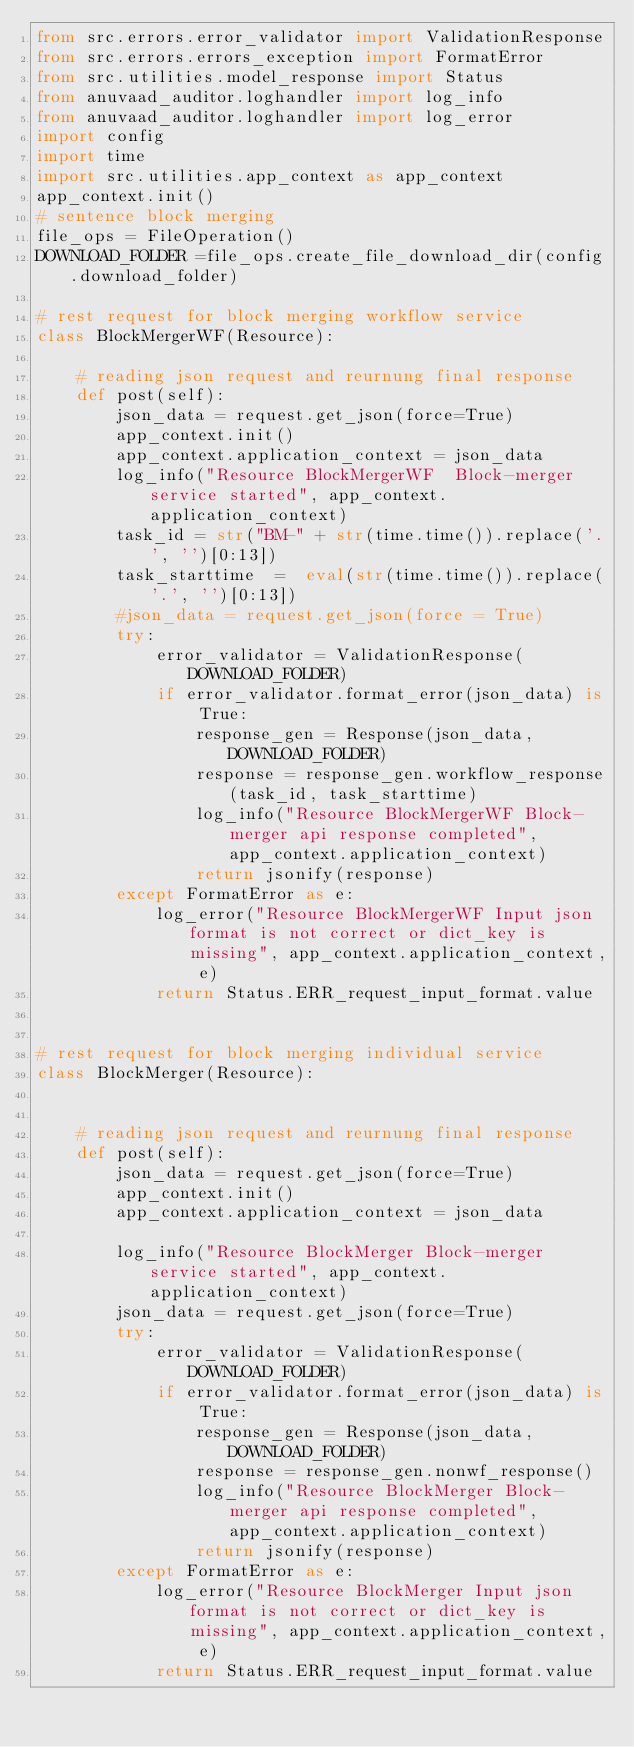Convert code to text. <code><loc_0><loc_0><loc_500><loc_500><_Python_>from src.errors.error_validator import ValidationResponse
from src.errors.errors_exception import FormatError
from src.utilities.model_response import Status
from anuvaad_auditor.loghandler import log_info
from anuvaad_auditor.loghandler import log_error
import config
import time
import src.utilities.app_context as app_context
app_context.init()
# sentence block merging
file_ops = FileOperation()
DOWNLOAD_FOLDER =file_ops.create_file_download_dir(config.download_folder)

# rest request for block merging workflow service
class BlockMergerWF(Resource):
    
    # reading json request and reurnung final response
    def post(self):
        json_data = request.get_json(force=True)
        app_context.init()
        app_context.application_context = json_data
        log_info("Resource BlockMergerWF  Block-merger service started", app_context.application_context)
        task_id = str("BM-" + str(time.time()).replace('.', '')[0:13])
        task_starttime  =  eval(str(time.time()).replace('.', '')[0:13])
        #json_data = request.get_json(force = True)
        try:
            error_validator = ValidationResponse(DOWNLOAD_FOLDER)
            if error_validator.format_error(json_data) is True:
                response_gen = Response(json_data, DOWNLOAD_FOLDER)
                response = response_gen.workflow_response(task_id, task_starttime)
                log_info("Resource BlockMergerWF Block-merger api response completed", app_context.application_context)
                return jsonify(response)
        except FormatError as e:
            log_error("Resource BlockMergerWF Input json format is not correct or dict_key is missing", app_context.application_context, e)
            return Status.ERR_request_input_format.value


# rest request for block merging individual service
class BlockMerger(Resource):


    # reading json request and reurnung final response
    def post(self):
        json_data = request.get_json(force=True)
        app_context.init()
        app_context.application_context = json_data

        log_info("Resource BlockMerger Block-merger service started", app_context.application_context)
        json_data = request.get_json(force=True)
        try:
            error_validator = ValidationResponse(DOWNLOAD_FOLDER)
            if error_validator.format_error(json_data) is True:
                response_gen = Response(json_data, DOWNLOAD_FOLDER)
                response = response_gen.nonwf_response()
                log_info("Resource BlockMerger Block-merger api response completed", app_context.application_context)
                return jsonify(response)
        except FormatError as e:
            log_error("Resource BlockMerger Input json format is not correct or dict_key is missing", app_context.application_context, e)
            return Status.ERR_request_input_format.value
</code> 